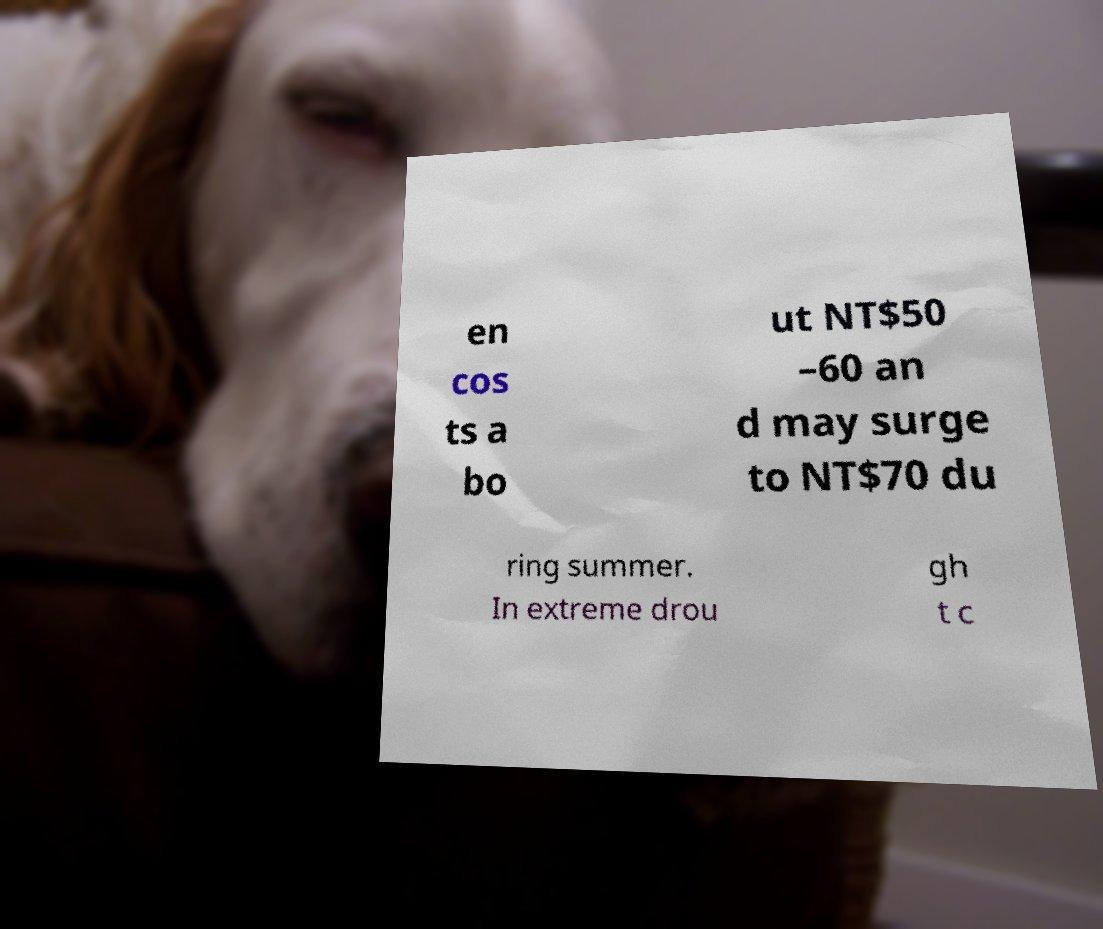What messages or text are displayed in this image? I need them in a readable, typed format. en cos ts a bo ut NT$50 –60 an d may surge to NT$70 du ring summer. In extreme drou gh t c 